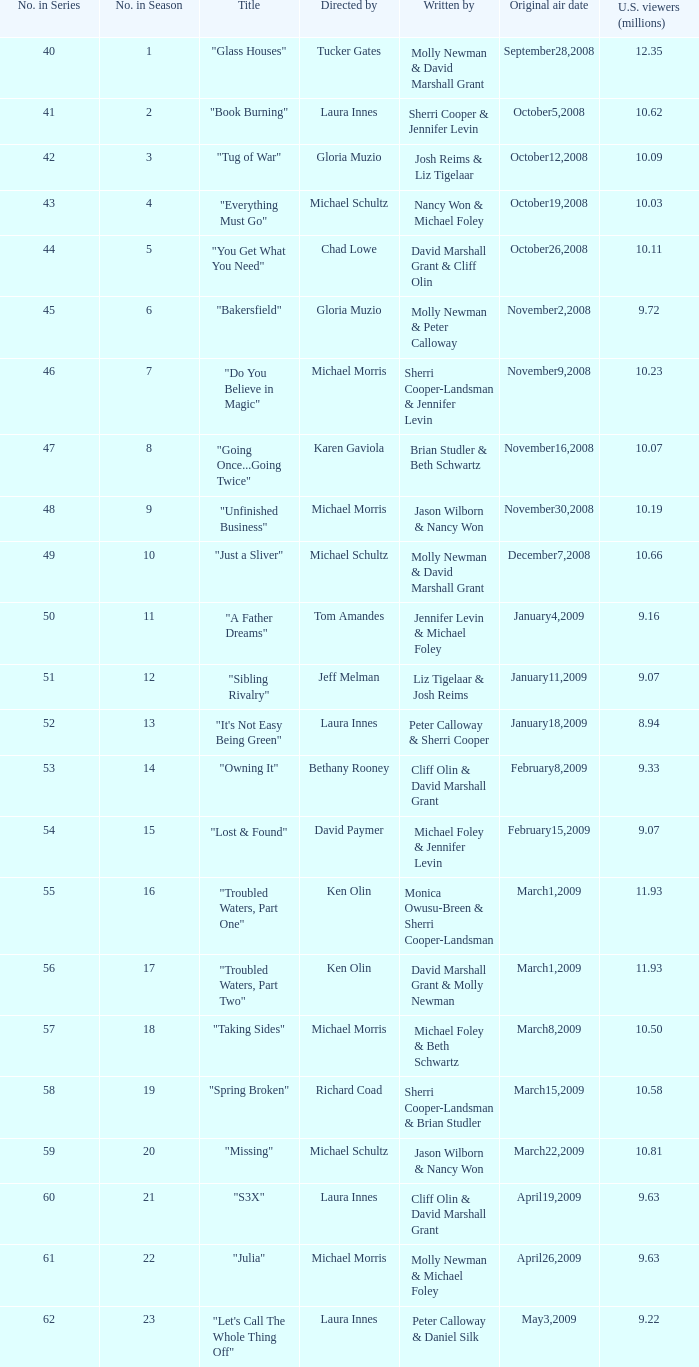When did the episode titled "Do you believe in magic" run for the first time? November9,2008. 